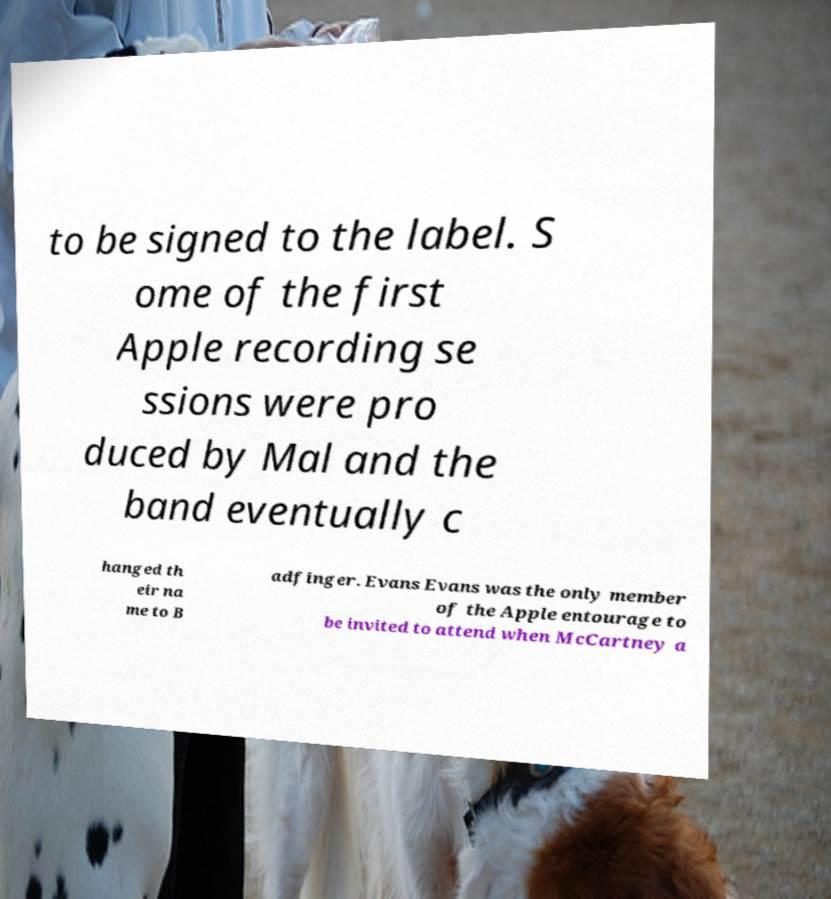I need the written content from this picture converted into text. Can you do that? to be signed to the label. S ome of the first Apple recording se ssions were pro duced by Mal and the band eventually c hanged th eir na me to B adfinger. Evans Evans was the only member of the Apple entourage to be invited to attend when McCartney a 